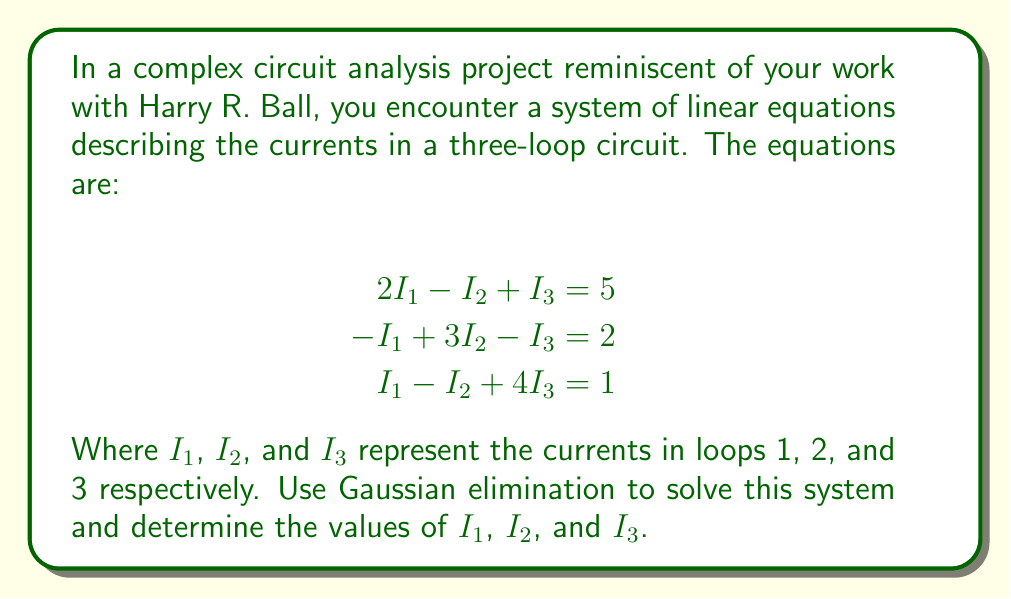What is the answer to this math problem? Let's solve this system using Gaussian elimination:

Step 1: Write the augmented matrix
$$\begin{bmatrix}
2 & -1 & 1 & | & 5 \\
-1 & 3 & -1 & | & 2 \\
1 & -1 & 4 & | & 1
\end{bmatrix}$$

Step 2: Use the first row to eliminate the -1 in the second row and the 1 in the third row
Add 1/2 of the first row to the second row:
$$\begin{bmatrix}
2 & -1 & 1 & | & 5 \\
0 & 2.5 & -0.5 & | & 4.5 \\
1 & -1 & 4 & | & 1
\end{bmatrix}$$

Subtract 1/2 of the first row from the third row:
$$\begin{bmatrix}
2 & -1 & 1 & | & 5 \\
0 & 2.5 & -0.5 & | & 4.5 \\
0 & -0.5 & 3.5 & | & -1.5
\end{bmatrix}$$

Step 3: Use the second row to eliminate the -0.5 in the third row
Add 1/5 of the second row to the third row:
$$\begin{bmatrix}
2 & -1 & 1 & | & 5 \\
0 & 2.5 & -0.5 & | & 4.5 \\
0 & 0 & 3.4 & | & -0.6
\end{bmatrix}$$

Step 4: Back-substitution
From the third row: $3.4I_3 = -0.6$, so $I_3 = -\frac{0.6}{3.4} = -\frac{5}{17}$

From the second row: $2.5I_2 - 0.5I_3 = 4.5$
Substituting $I_3$: $2.5I_2 - 0.5(-\frac{5}{17}) = 4.5$
$2.5I_2 = 4.5 + \frac{5}{34} = \frac{158}{34}$
$I_2 = \frac{158}{85} = \frac{158}{85}$

From the first row: $2I_1 - I_2 + I_3 = 5$
Substituting $I_2$ and $I_3$: $2I_1 - \frac{158}{85} - \frac{5}{17} = 5$
$2I_1 = 5 + \frac{158}{85} + \frac{5}{17} = \frac{850}{85} + \frac{158}{85} + \frac{25}{85} = \frac{1033}{85}$
$I_1 = \frac{1033}{170}$
Answer: $I_1 = \frac{1033}{170}$, $I_2 = \frac{158}{85}$, $I_3 = -\frac{5}{17}$ 